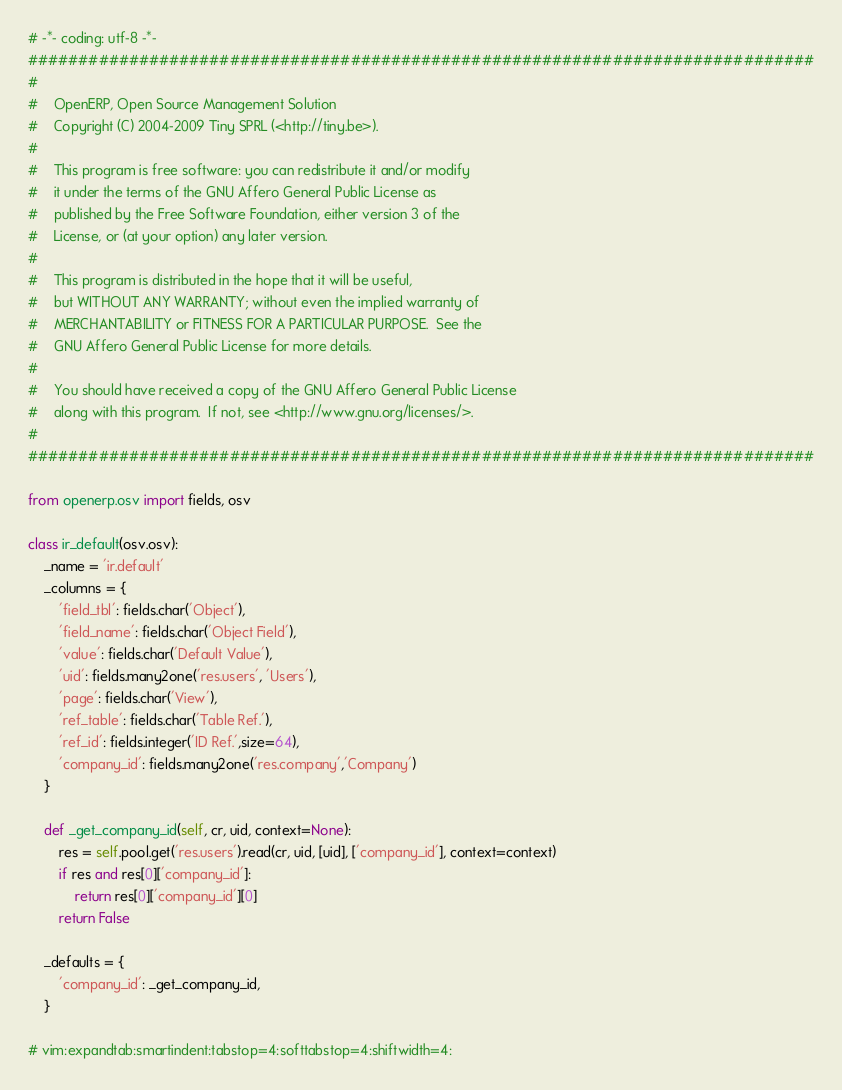Convert code to text. <code><loc_0><loc_0><loc_500><loc_500><_Python_># -*- coding: utf-8 -*-
##############################################################################
#    
#    OpenERP, Open Source Management Solution
#    Copyright (C) 2004-2009 Tiny SPRL (<http://tiny.be>).
#
#    This program is free software: you can redistribute it and/or modify
#    it under the terms of the GNU Affero General Public License as
#    published by the Free Software Foundation, either version 3 of the
#    License, or (at your option) any later version.
#
#    This program is distributed in the hope that it will be useful,
#    but WITHOUT ANY WARRANTY; without even the implied warranty of
#    MERCHANTABILITY or FITNESS FOR A PARTICULAR PURPOSE.  See the
#    GNU Affero General Public License for more details.
#
#    You should have received a copy of the GNU Affero General Public License
#    along with this program.  If not, see <http://www.gnu.org/licenses/>.     
#
##############################################################################

from openerp.osv import fields, osv

class ir_default(osv.osv):
    _name = 'ir.default'
    _columns = {
        'field_tbl': fields.char('Object'),
        'field_name': fields.char('Object Field'),
        'value': fields.char('Default Value'),
        'uid': fields.many2one('res.users', 'Users'),
        'page': fields.char('View'),
        'ref_table': fields.char('Table Ref.'),
        'ref_id': fields.integer('ID Ref.',size=64),
        'company_id': fields.many2one('res.company','Company')
    }

    def _get_company_id(self, cr, uid, context=None):
        res = self.pool.get('res.users').read(cr, uid, [uid], ['company_id'], context=context)
        if res and res[0]['company_id']:
            return res[0]['company_id'][0]
        return False

    _defaults = {
        'company_id': _get_company_id,
    }

# vim:expandtab:smartindent:tabstop=4:softtabstop=4:shiftwidth=4:
</code> 